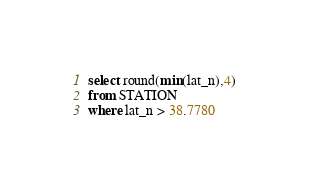Convert code to text. <code><loc_0><loc_0><loc_500><loc_500><_SQL_>select round(min(lat_n),4)
from STATION
where lat_n > 38.7780
</code> 